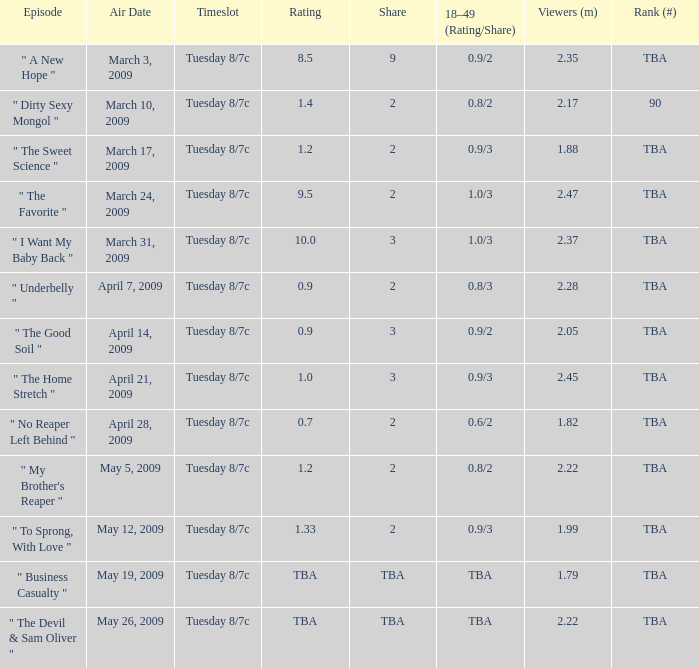What is the rating of the show ranked tba, aired on April 21, 2009? 1.0. 